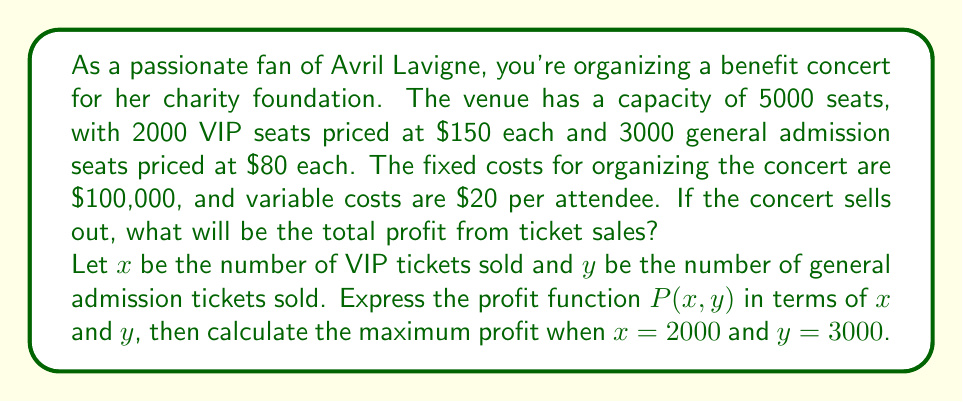Help me with this question. Let's approach this step-by-step:

1) First, we need to set up the profit function. Profit is calculated as Revenue - Costs.

2) Revenue:
   - VIP tickets: $150x$
   - General admission tickets: $80y$
   Total revenue: $R(x,y) = 150x + 80y$

3) Costs:
   - Fixed costs: $100,000
   - Variable costs: $20 per attendee, so $20(x+y)$
   Total costs: $C(x,y) = 100,000 + 20(x+y)$

4) Profit function:
   $$P(x,y) = R(x,y) - C(x,y)$$
   $$P(x,y) = (150x + 80y) - (100,000 + 20(x+y))$$
   $$P(x,y) = 150x + 80y - 100,000 - 20x - 20y$$
   $$P(x,y) = 130x + 60y - 100,000$$

5) For a sold-out concert, $x = 2000$ and $y = 3000$. Let's substitute these values:

   $$P(2000, 3000) = 130(2000) + 60(3000) - 100,000$$
   $$= 260,000 + 180,000 - 100,000$$
   $$= 340,000$$

Therefore, the total profit from a sold-out concert would be $340,000.
Answer: $340,000 